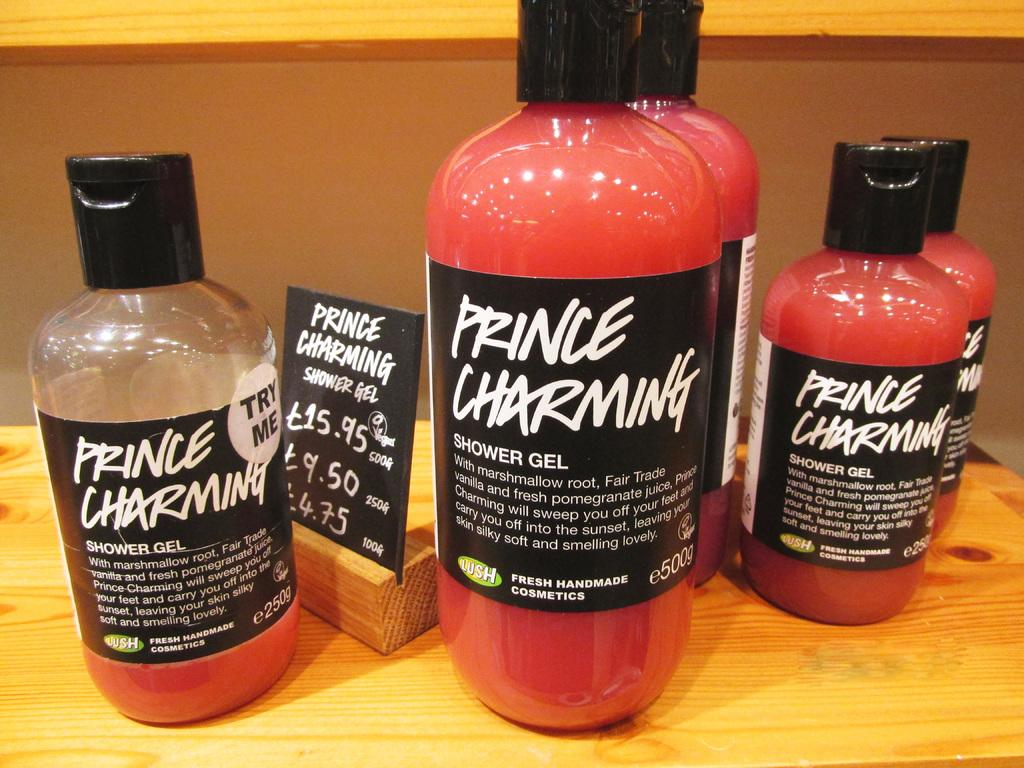<image>
Relay a brief, clear account of the picture shown. Several bottles of Prince Charming shower gel are sitting on a shelf. 